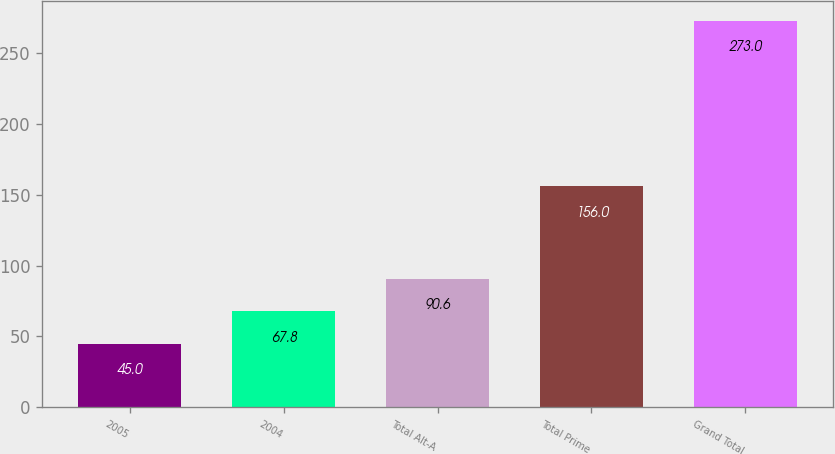Convert chart to OTSL. <chart><loc_0><loc_0><loc_500><loc_500><bar_chart><fcel>2005<fcel>2004<fcel>Total Alt-A<fcel>Total Prime<fcel>Grand Total<nl><fcel>45<fcel>67.8<fcel>90.6<fcel>156<fcel>273<nl></chart> 